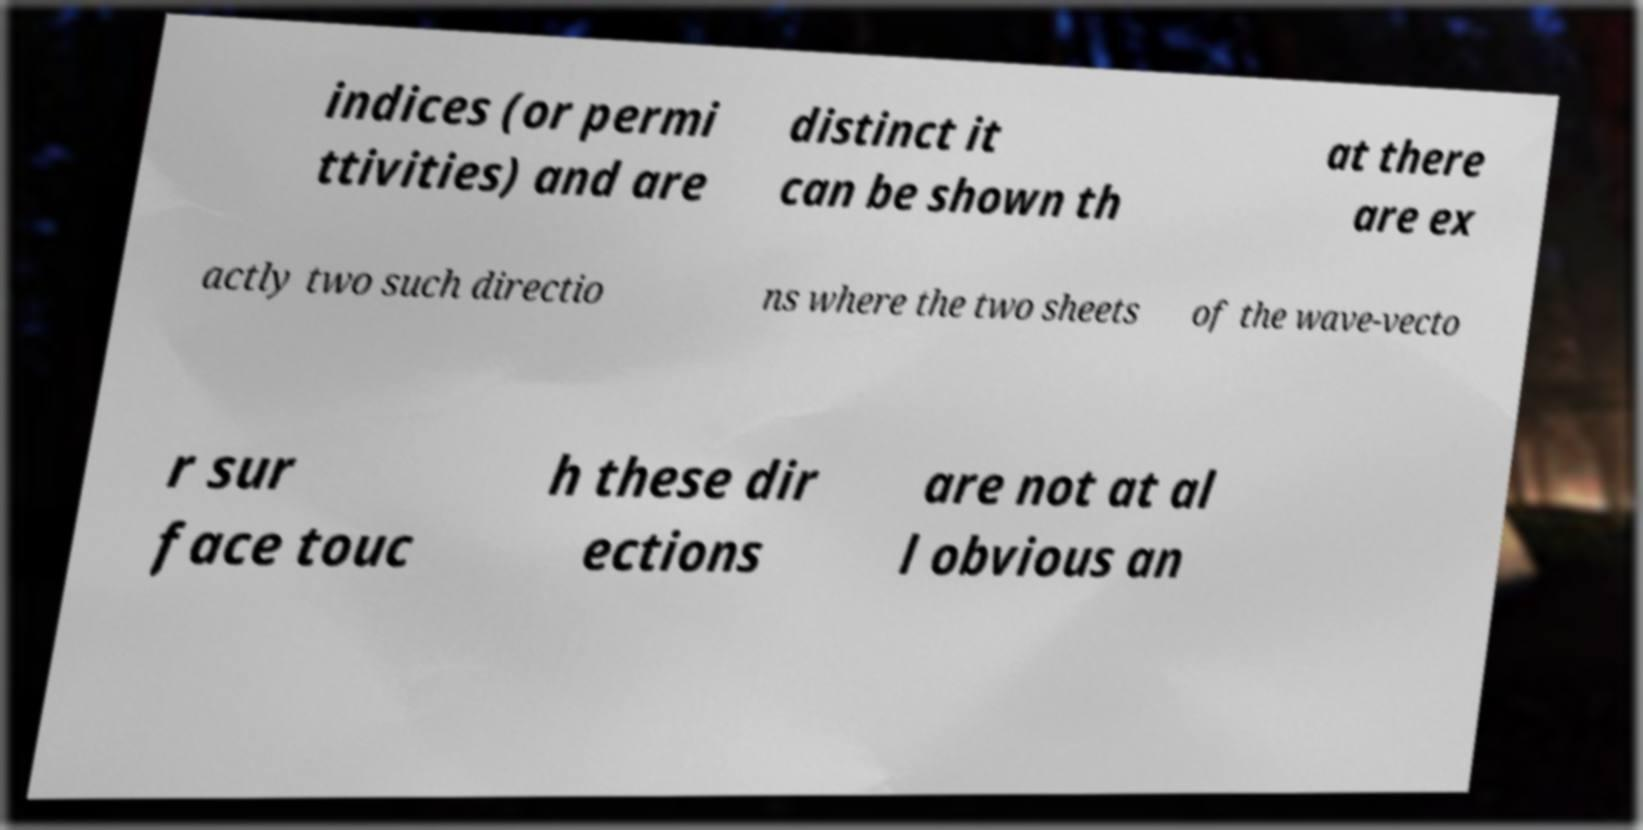There's text embedded in this image that I need extracted. Can you transcribe it verbatim? indices (or permi ttivities) and are distinct it can be shown th at there are ex actly two such directio ns where the two sheets of the wave-vecto r sur face touc h these dir ections are not at al l obvious an 